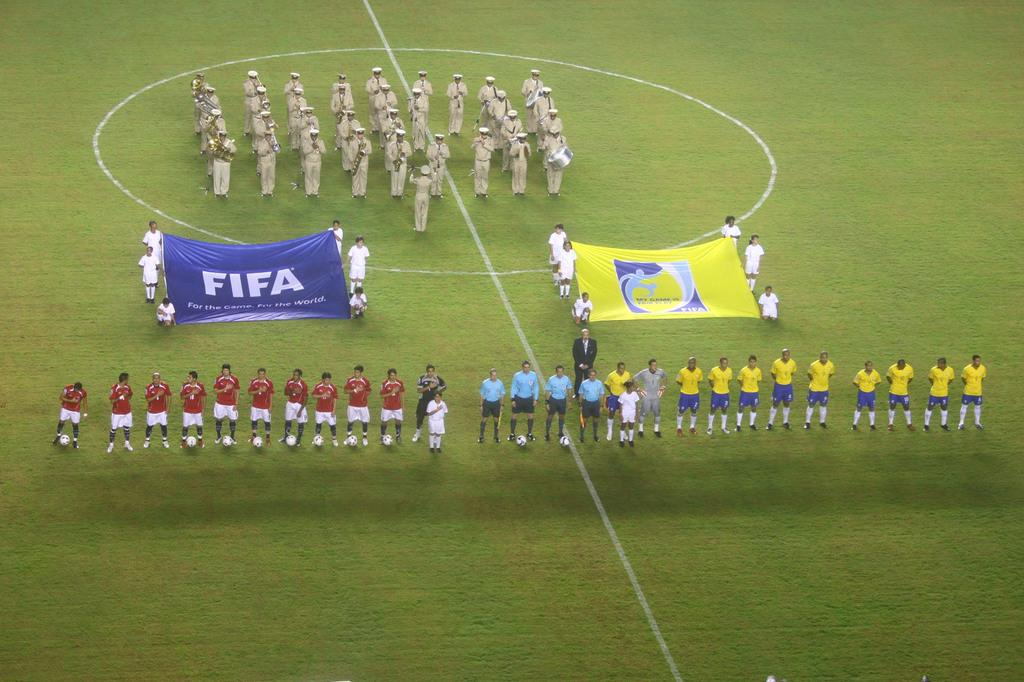<image>
Relay a brief, clear account of the picture shown. A soccer game is about to begin and the players are lined up on the field holding a flag that says FIFA. 